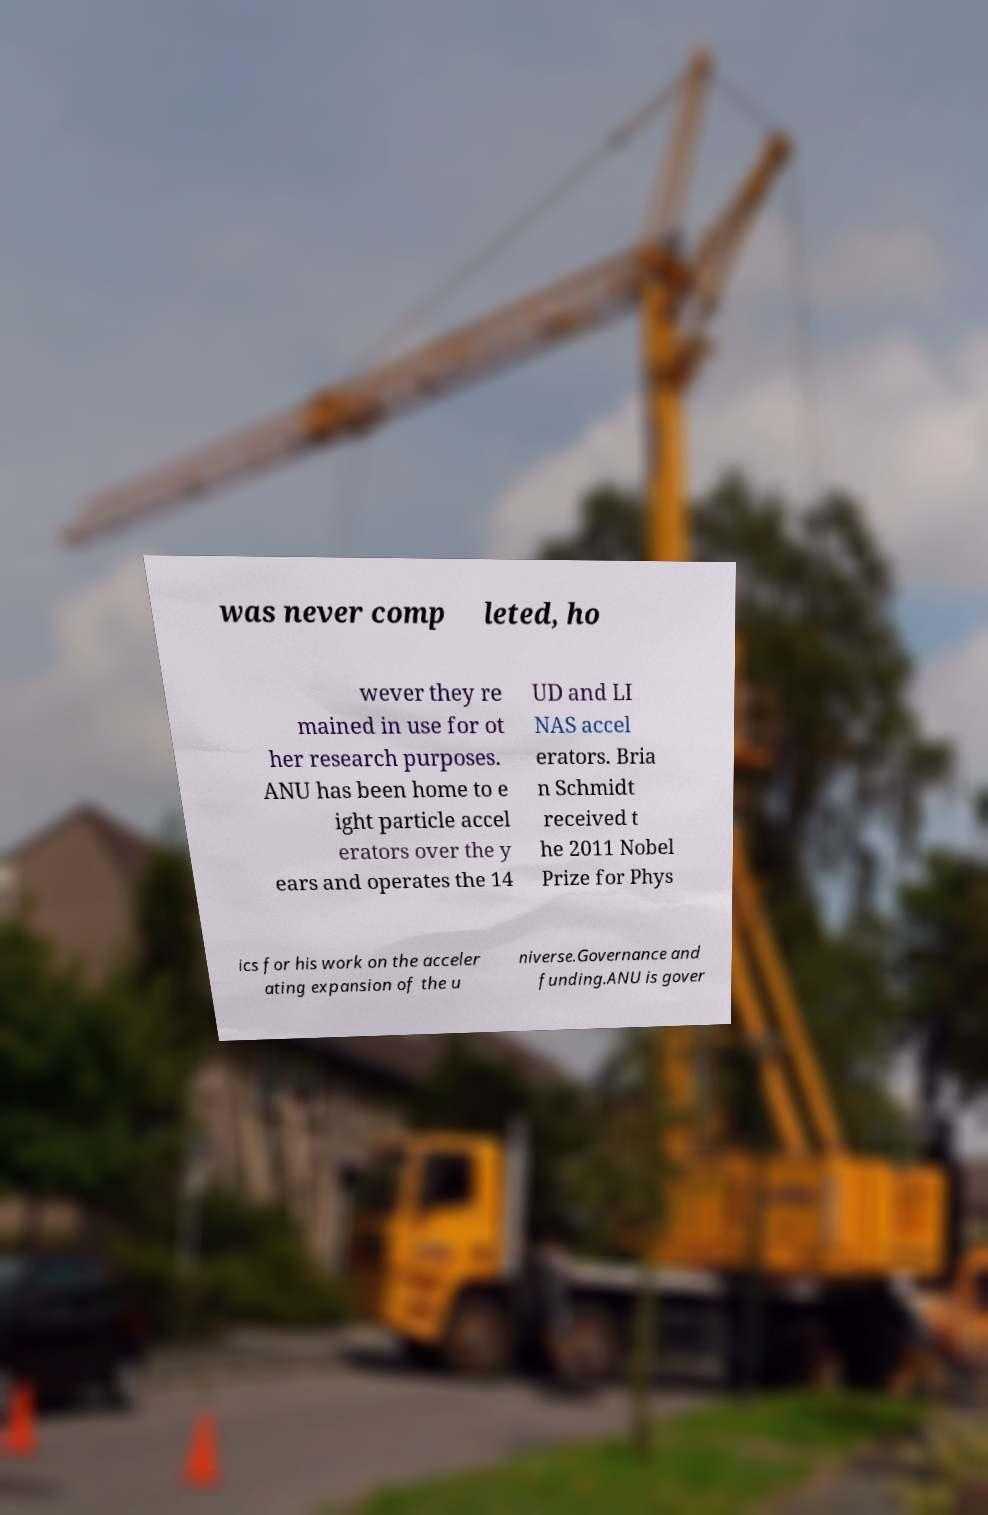Please read and relay the text visible in this image. What does it say? was never comp leted, ho wever they re mained in use for ot her research purposes. ANU has been home to e ight particle accel erators over the y ears and operates the 14 UD and LI NAS accel erators. Bria n Schmidt received t he 2011 Nobel Prize for Phys ics for his work on the acceler ating expansion of the u niverse.Governance and funding.ANU is gover 